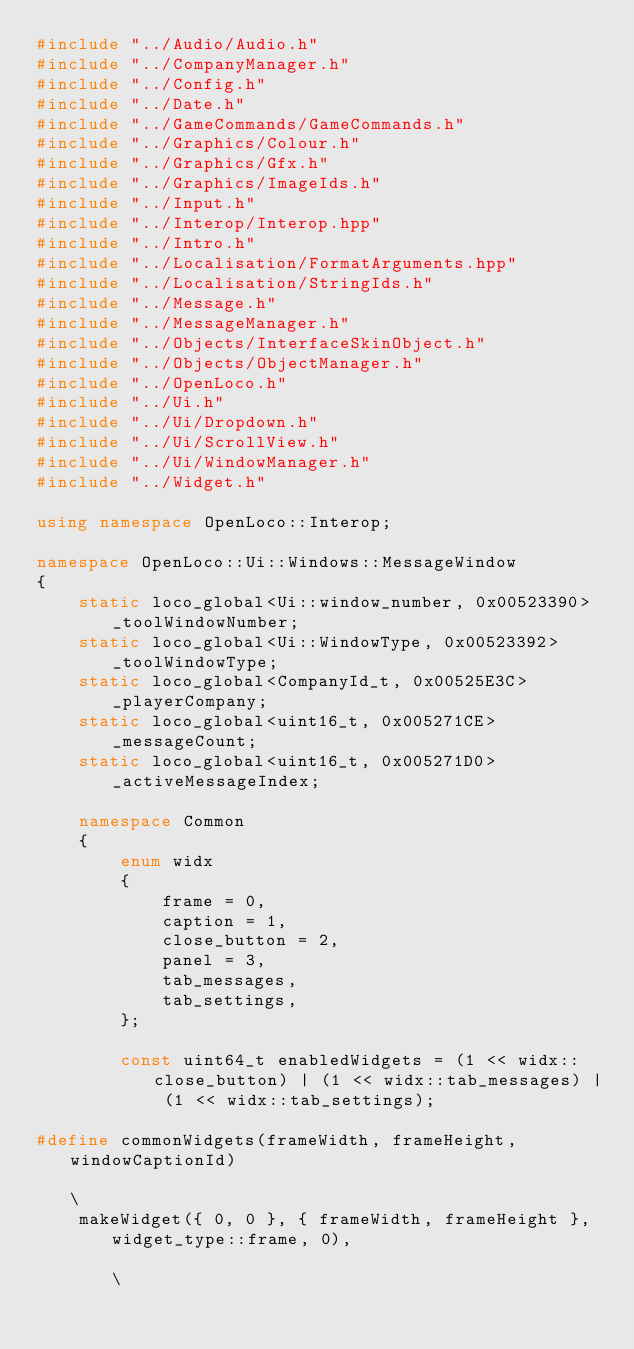Convert code to text. <code><loc_0><loc_0><loc_500><loc_500><_C++_>#include "../Audio/Audio.h"
#include "../CompanyManager.h"
#include "../Config.h"
#include "../Date.h"
#include "../GameCommands/GameCommands.h"
#include "../Graphics/Colour.h"
#include "../Graphics/Gfx.h"
#include "../Graphics/ImageIds.h"
#include "../Input.h"
#include "../Interop/Interop.hpp"
#include "../Intro.h"
#include "../Localisation/FormatArguments.hpp"
#include "../Localisation/StringIds.h"
#include "../Message.h"
#include "../MessageManager.h"
#include "../Objects/InterfaceSkinObject.h"
#include "../Objects/ObjectManager.h"
#include "../OpenLoco.h"
#include "../Ui.h"
#include "../Ui/Dropdown.h"
#include "../Ui/ScrollView.h"
#include "../Ui/WindowManager.h"
#include "../Widget.h"

using namespace OpenLoco::Interop;

namespace OpenLoco::Ui::Windows::MessageWindow
{
    static loco_global<Ui::window_number, 0x00523390> _toolWindowNumber;
    static loco_global<Ui::WindowType, 0x00523392> _toolWindowType;
    static loco_global<CompanyId_t, 0x00525E3C> _playerCompany;
    static loco_global<uint16_t, 0x005271CE> _messageCount;
    static loco_global<uint16_t, 0x005271D0> _activeMessageIndex;

    namespace Common
    {
        enum widx
        {
            frame = 0,
            caption = 1,
            close_button = 2,
            panel = 3,
            tab_messages,
            tab_settings,
        };

        const uint64_t enabledWidgets = (1 << widx::close_button) | (1 << widx::tab_messages) | (1 << widx::tab_settings);

#define commonWidgets(frameWidth, frameHeight, windowCaptionId)                                                                        \
    makeWidget({ 0, 0 }, { frameWidth, frameHeight }, widget_type::frame, 0),                                                          \</code> 